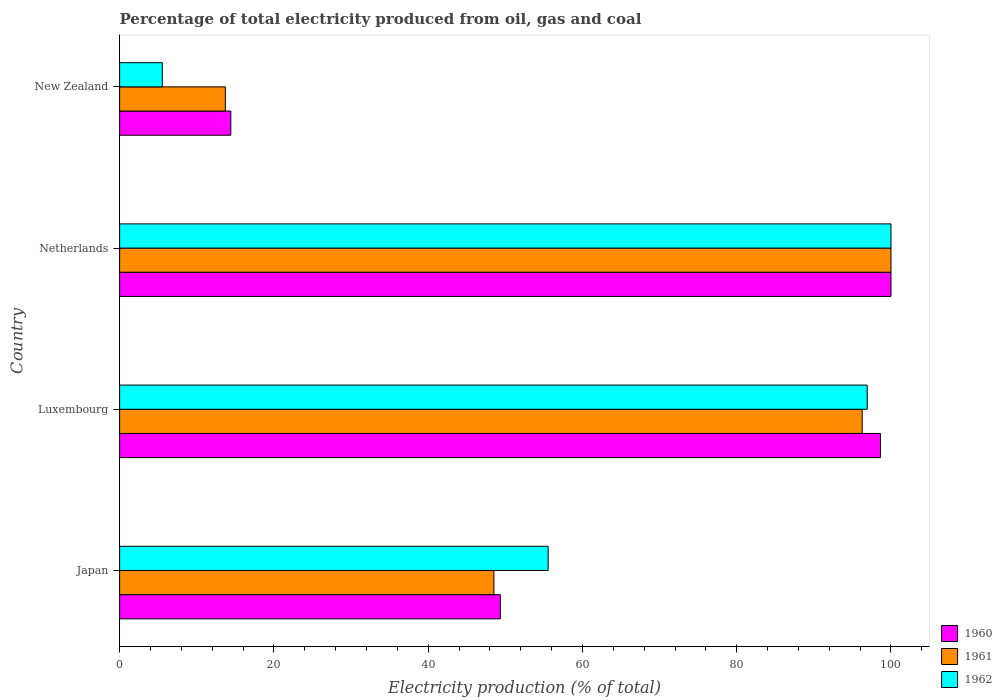Are the number of bars on each tick of the Y-axis equal?
Give a very brief answer. Yes. How many bars are there on the 2nd tick from the top?
Your response must be concise. 3. In how many cases, is the number of bars for a given country not equal to the number of legend labels?
Your answer should be compact. 0. Across all countries, what is the maximum electricity production in in 1962?
Make the answer very short. 100. Across all countries, what is the minimum electricity production in in 1960?
Provide a short and direct response. 14.42. In which country was the electricity production in in 1960 maximum?
Offer a terse response. Netherlands. In which country was the electricity production in in 1961 minimum?
Provide a short and direct response. New Zealand. What is the total electricity production in in 1962 in the graph?
Provide a succinct answer. 258.01. What is the difference between the electricity production in in 1960 in Luxembourg and that in New Zealand?
Provide a short and direct response. 84.22. What is the difference between the electricity production in in 1960 in New Zealand and the electricity production in in 1961 in Netherlands?
Your answer should be compact. -85.58. What is the average electricity production in in 1960 per country?
Offer a very short reply. 65.6. What is the difference between the electricity production in in 1962 and electricity production in in 1961 in Japan?
Make the answer very short. 7.03. In how many countries, is the electricity production in in 1962 greater than 24 %?
Offer a terse response. 3. What is the ratio of the electricity production in in 1960 in Japan to that in Luxembourg?
Ensure brevity in your answer.  0.5. Is the electricity production in in 1962 in Japan less than that in Netherlands?
Your response must be concise. Yes. What is the difference between the highest and the second highest electricity production in in 1962?
Your answer should be compact. 3.08. What is the difference between the highest and the lowest electricity production in in 1960?
Keep it short and to the point. 85.58. Is the sum of the electricity production in in 1962 in Netherlands and New Zealand greater than the maximum electricity production in in 1960 across all countries?
Offer a terse response. Yes. What is the difference between two consecutive major ticks on the X-axis?
Your response must be concise. 20. Does the graph contain any zero values?
Your answer should be compact. No. Does the graph contain grids?
Provide a succinct answer. No. Where does the legend appear in the graph?
Give a very brief answer. Bottom right. How many legend labels are there?
Your response must be concise. 3. How are the legend labels stacked?
Ensure brevity in your answer.  Vertical. What is the title of the graph?
Offer a terse response. Percentage of total electricity produced from oil, gas and coal. Does "1960" appear as one of the legend labels in the graph?
Your response must be concise. Yes. What is the label or title of the X-axis?
Your answer should be compact. Electricity production (% of total). What is the Electricity production (% of total) in 1960 in Japan?
Your answer should be very brief. 49.35. What is the Electricity production (% of total) of 1961 in Japan?
Make the answer very short. 48.52. What is the Electricity production (% of total) in 1962 in Japan?
Offer a terse response. 55.56. What is the Electricity production (% of total) of 1960 in Luxembourg?
Your response must be concise. 98.63. What is the Electricity production (% of total) in 1961 in Luxembourg?
Offer a very short reply. 96.27. What is the Electricity production (% of total) of 1962 in Luxembourg?
Offer a very short reply. 96.92. What is the Electricity production (% of total) of 1962 in Netherlands?
Provide a succinct answer. 100. What is the Electricity production (% of total) of 1960 in New Zealand?
Ensure brevity in your answer.  14.42. What is the Electricity production (% of total) of 1961 in New Zealand?
Offer a very short reply. 13.71. What is the Electricity production (% of total) of 1962 in New Zealand?
Offer a terse response. 5.54. Across all countries, what is the maximum Electricity production (% of total) in 1961?
Ensure brevity in your answer.  100. Across all countries, what is the maximum Electricity production (% of total) of 1962?
Your response must be concise. 100. Across all countries, what is the minimum Electricity production (% of total) in 1960?
Your answer should be compact. 14.42. Across all countries, what is the minimum Electricity production (% of total) of 1961?
Offer a terse response. 13.71. Across all countries, what is the minimum Electricity production (% of total) in 1962?
Keep it short and to the point. 5.54. What is the total Electricity production (% of total) of 1960 in the graph?
Keep it short and to the point. 262.4. What is the total Electricity production (% of total) of 1961 in the graph?
Ensure brevity in your answer.  258.5. What is the total Electricity production (% of total) in 1962 in the graph?
Give a very brief answer. 258.01. What is the difference between the Electricity production (% of total) of 1960 in Japan and that in Luxembourg?
Keep it short and to the point. -49.28. What is the difference between the Electricity production (% of total) of 1961 in Japan and that in Luxembourg?
Keep it short and to the point. -47.75. What is the difference between the Electricity production (% of total) in 1962 in Japan and that in Luxembourg?
Keep it short and to the point. -41.36. What is the difference between the Electricity production (% of total) in 1960 in Japan and that in Netherlands?
Your answer should be compact. -50.65. What is the difference between the Electricity production (% of total) of 1961 in Japan and that in Netherlands?
Offer a terse response. -51.48. What is the difference between the Electricity production (% of total) in 1962 in Japan and that in Netherlands?
Provide a short and direct response. -44.44. What is the difference between the Electricity production (% of total) of 1960 in Japan and that in New Zealand?
Your response must be concise. 34.93. What is the difference between the Electricity production (% of total) of 1961 in Japan and that in New Zealand?
Give a very brief answer. 34.82. What is the difference between the Electricity production (% of total) of 1962 in Japan and that in New Zealand?
Give a very brief answer. 50.02. What is the difference between the Electricity production (% of total) in 1960 in Luxembourg and that in Netherlands?
Your answer should be compact. -1.37. What is the difference between the Electricity production (% of total) in 1961 in Luxembourg and that in Netherlands?
Offer a terse response. -3.73. What is the difference between the Electricity production (% of total) of 1962 in Luxembourg and that in Netherlands?
Ensure brevity in your answer.  -3.08. What is the difference between the Electricity production (% of total) in 1960 in Luxembourg and that in New Zealand?
Offer a very short reply. 84.22. What is the difference between the Electricity production (% of total) in 1961 in Luxembourg and that in New Zealand?
Make the answer very short. 82.56. What is the difference between the Electricity production (% of total) of 1962 in Luxembourg and that in New Zealand?
Make the answer very short. 91.38. What is the difference between the Electricity production (% of total) in 1960 in Netherlands and that in New Zealand?
Offer a terse response. 85.58. What is the difference between the Electricity production (% of total) in 1961 in Netherlands and that in New Zealand?
Keep it short and to the point. 86.29. What is the difference between the Electricity production (% of total) in 1962 in Netherlands and that in New Zealand?
Keep it short and to the point. 94.46. What is the difference between the Electricity production (% of total) in 1960 in Japan and the Electricity production (% of total) in 1961 in Luxembourg?
Your answer should be compact. -46.92. What is the difference between the Electricity production (% of total) of 1960 in Japan and the Electricity production (% of total) of 1962 in Luxembourg?
Make the answer very short. -47.57. What is the difference between the Electricity production (% of total) of 1961 in Japan and the Electricity production (% of total) of 1962 in Luxembourg?
Provide a short and direct response. -48.39. What is the difference between the Electricity production (% of total) of 1960 in Japan and the Electricity production (% of total) of 1961 in Netherlands?
Keep it short and to the point. -50.65. What is the difference between the Electricity production (% of total) of 1960 in Japan and the Electricity production (% of total) of 1962 in Netherlands?
Offer a terse response. -50.65. What is the difference between the Electricity production (% of total) of 1961 in Japan and the Electricity production (% of total) of 1962 in Netherlands?
Keep it short and to the point. -51.48. What is the difference between the Electricity production (% of total) in 1960 in Japan and the Electricity production (% of total) in 1961 in New Zealand?
Offer a terse response. 35.64. What is the difference between the Electricity production (% of total) of 1960 in Japan and the Electricity production (% of total) of 1962 in New Zealand?
Make the answer very short. 43.81. What is the difference between the Electricity production (% of total) of 1961 in Japan and the Electricity production (% of total) of 1962 in New Zealand?
Your answer should be very brief. 42.99. What is the difference between the Electricity production (% of total) in 1960 in Luxembourg and the Electricity production (% of total) in 1961 in Netherlands?
Offer a very short reply. -1.37. What is the difference between the Electricity production (% of total) in 1960 in Luxembourg and the Electricity production (% of total) in 1962 in Netherlands?
Keep it short and to the point. -1.37. What is the difference between the Electricity production (% of total) of 1961 in Luxembourg and the Electricity production (% of total) of 1962 in Netherlands?
Give a very brief answer. -3.73. What is the difference between the Electricity production (% of total) of 1960 in Luxembourg and the Electricity production (% of total) of 1961 in New Zealand?
Offer a terse response. 84.93. What is the difference between the Electricity production (% of total) in 1960 in Luxembourg and the Electricity production (% of total) in 1962 in New Zealand?
Your response must be concise. 93.1. What is the difference between the Electricity production (% of total) in 1961 in Luxembourg and the Electricity production (% of total) in 1962 in New Zealand?
Offer a terse response. 90.73. What is the difference between the Electricity production (% of total) in 1960 in Netherlands and the Electricity production (% of total) in 1961 in New Zealand?
Ensure brevity in your answer.  86.29. What is the difference between the Electricity production (% of total) of 1960 in Netherlands and the Electricity production (% of total) of 1962 in New Zealand?
Make the answer very short. 94.46. What is the difference between the Electricity production (% of total) of 1961 in Netherlands and the Electricity production (% of total) of 1962 in New Zealand?
Keep it short and to the point. 94.46. What is the average Electricity production (% of total) of 1960 per country?
Offer a terse response. 65.6. What is the average Electricity production (% of total) in 1961 per country?
Make the answer very short. 64.63. What is the average Electricity production (% of total) of 1962 per country?
Keep it short and to the point. 64.5. What is the difference between the Electricity production (% of total) in 1960 and Electricity production (% of total) in 1961 in Japan?
Make the answer very short. 0.83. What is the difference between the Electricity production (% of total) of 1960 and Electricity production (% of total) of 1962 in Japan?
Offer a very short reply. -6.2. What is the difference between the Electricity production (% of total) of 1961 and Electricity production (% of total) of 1962 in Japan?
Ensure brevity in your answer.  -7.03. What is the difference between the Electricity production (% of total) in 1960 and Electricity production (% of total) in 1961 in Luxembourg?
Provide a succinct answer. 2.36. What is the difference between the Electricity production (% of total) in 1960 and Electricity production (% of total) in 1962 in Luxembourg?
Offer a very short reply. 1.72. What is the difference between the Electricity production (% of total) in 1961 and Electricity production (% of total) in 1962 in Luxembourg?
Your answer should be compact. -0.65. What is the difference between the Electricity production (% of total) of 1960 and Electricity production (% of total) of 1961 in Netherlands?
Ensure brevity in your answer.  0. What is the difference between the Electricity production (% of total) in 1961 and Electricity production (% of total) in 1962 in Netherlands?
Provide a short and direct response. 0. What is the difference between the Electricity production (% of total) in 1960 and Electricity production (% of total) in 1961 in New Zealand?
Your answer should be compact. 0.71. What is the difference between the Electricity production (% of total) in 1960 and Electricity production (% of total) in 1962 in New Zealand?
Keep it short and to the point. 8.88. What is the difference between the Electricity production (% of total) in 1961 and Electricity production (% of total) in 1962 in New Zealand?
Your answer should be compact. 8.17. What is the ratio of the Electricity production (% of total) in 1960 in Japan to that in Luxembourg?
Provide a short and direct response. 0.5. What is the ratio of the Electricity production (% of total) in 1961 in Japan to that in Luxembourg?
Provide a succinct answer. 0.5. What is the ratio of the Electricity production (% of total) in 1962 in Japan to that in Luxembourg?
Your response must be concise. 0.57. What is the ratio of the Electricity production (% of total) in 1960 in Japan to that in Netherlands?
Your answer should be compact. 0.49. What is the ratio of the Electricity production (% of total) of 1961 in Japan to that in Netherlands?
Make the answer very short. 0.49. What is the ratio of the Electricity production (% of total) of 1962 in Japan to that in Netherlands?
Your response must be concise. 0.56. What is the ratio of the Electricity production (% of total) in 1960 in Japan to that in New Zealand?
Give a very brief answer. 3.42. What is the ratio of the Electricity production (% of total) in 1961 in Japan to that in New Zealand?
Offer a very short reply. 3.54. What is the ratio of the Electricity production (% of total) in 1962 in Japan to that in New Zealand?
Your answer should be compact. 10.03. What is the ratio of the Electricity production (% of total) of 1960 in Luxembourg to that in Netherlands?
Ensure brevity in your answer.  0.99. What is the ratio of the Electricity production (% of total) in 1961 in Luxembourg to that in Netherlands?
Keep it short and to the point. 0.96. What is the ratio of the Electricity production (% of total) in 1962 in Luxembourg to that in Netherlands?
Make the answer very short. 0.97. What is the ratio of the Electricity production (% of total) of 1960 in Luxembourg to that in New Zealand?
Provide a short and direct response. 6.84. What is the ratio of the Electricity production (% of total) of 1961 in Luxembourg to that in New Zealand?
Offer a terse response. 7.02. What is the ratio of the Electricity production (% of total) in 1962 in Luxembourg to that in New Zealand?
Ensure brevity in your answer.  17.51. What is the ratio of the Electricity production (% of total) of 1960 in Netherlands to that in New Zealand?
Make the answer very short. 6.94. What is the ratio of the Electricity production (% of total) in 1961 in Netherlands to that in New Zealand?
Offer a very short reply. 7.29. What is the ratio of the Electricity production (% of total) in 1962 in Netherlands to that in New Zealand?
Provide a short and direct response. 18.06. What is the difference between the highest and the second highest Electricity production (% of total) of 1960?
Offer a very short reply. 1.37. What is the difference between the highest and the second highest Electricity production (% of total) of 1961?
Your answer should be very brief. 3.73. What is the difference between the highest and the second highest Electricity production (% of total) of 1962?
Your response must be concise. 3.08. What is the difference between the highest and the lowest Electricity production (% of total) of 1960?
Offer a terse response. 85.58. What is the difference between the highest and the lowest Electricity production (% of total) of 1961?
Provide a short and direct response. 86.29. What is the difference between the highest and the lowest Electricity production (% of total) of 1962?
Make the answer very short. 94.46. 